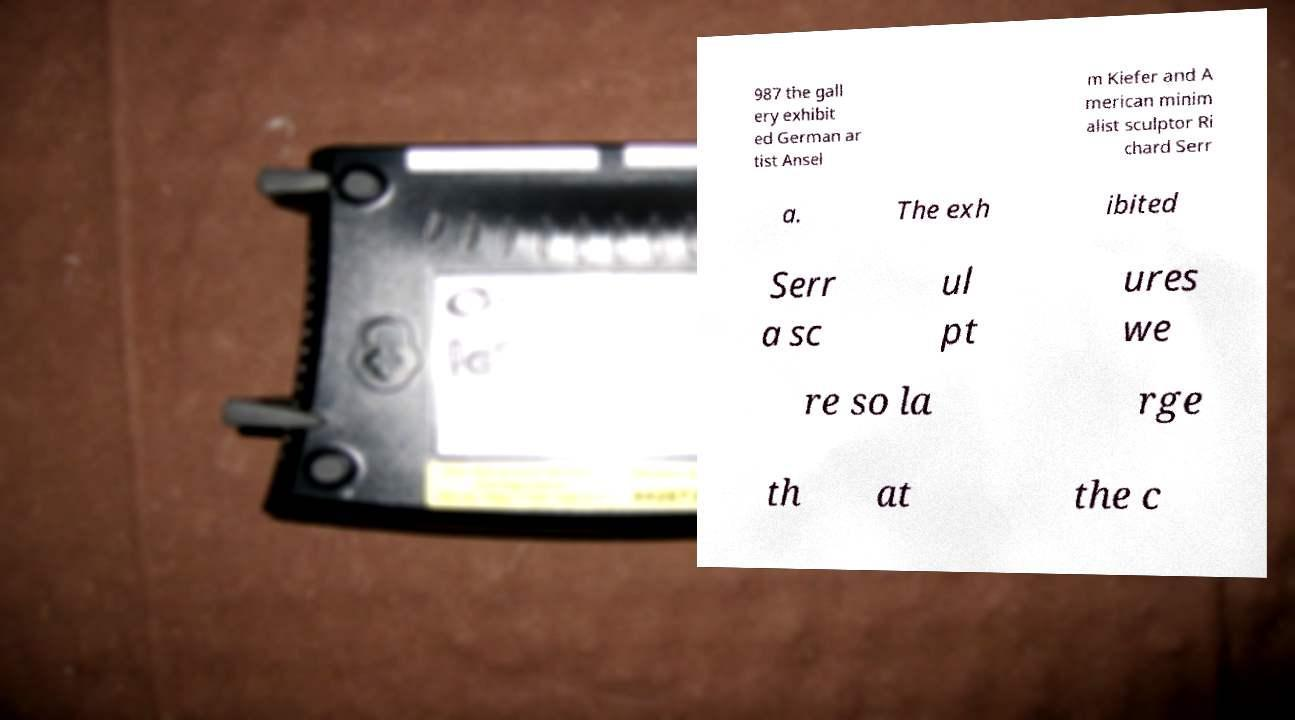Can you read and provide the text displayed in the image?This photo seems to have some interesting text. Can you extract and type it out for me? 987 the gall ery exhibit ed German ar tist Ansel m Kiefer and A merican minim alist sculptor Ri chard Serr a. The exh ibited Serr a sc ul pt ures we re so la rge th at the c 